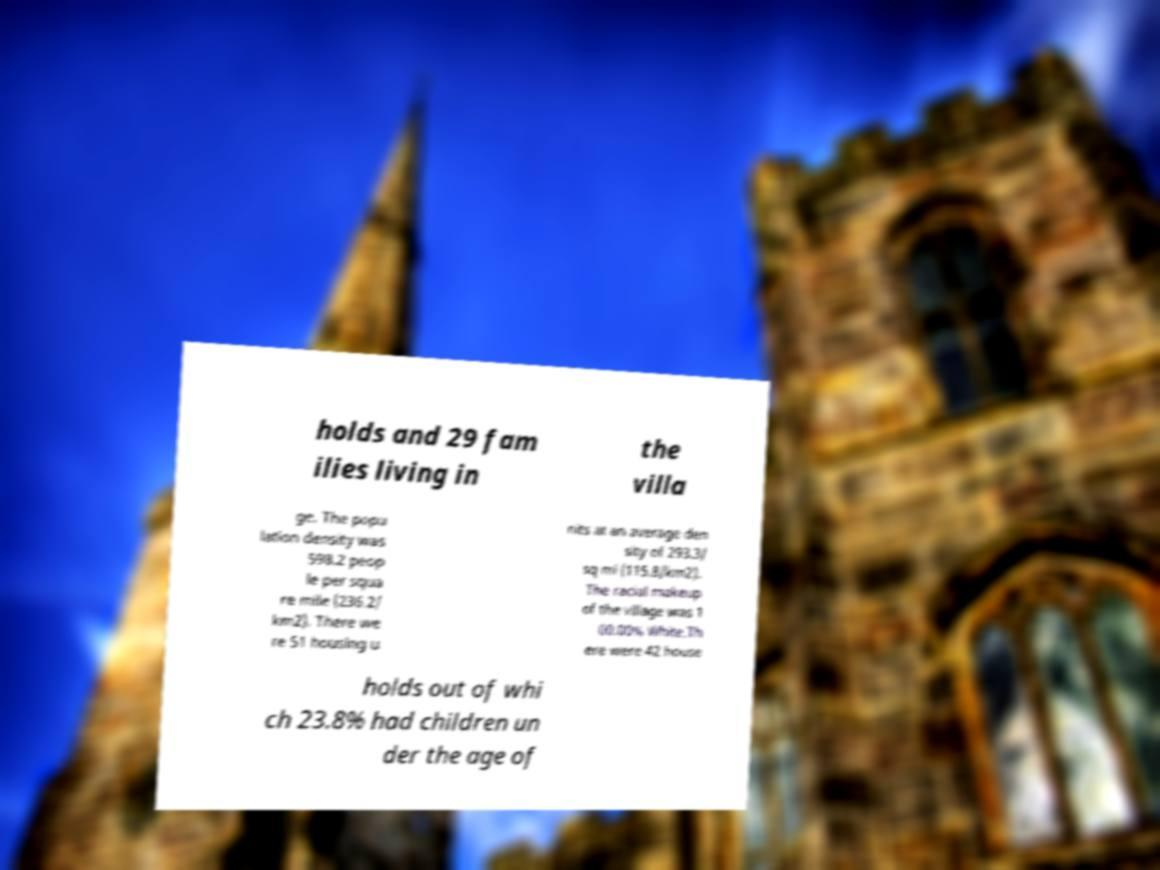For documentation purposes, I need the text within this image transcribed. Could you provide that? holds and 29 fam ilies living in the villa ge. The popu lation density was 598.2 peop le per squa re mile (236.2/ km2). There we re 51 housing u nits at an average den sity of 293.3/ sq mi (115.8/km2). The racial makeup of the village was 1 00.00% White.Th ere were 42 house holds out of whi ch 23.8% had children un der the age of 